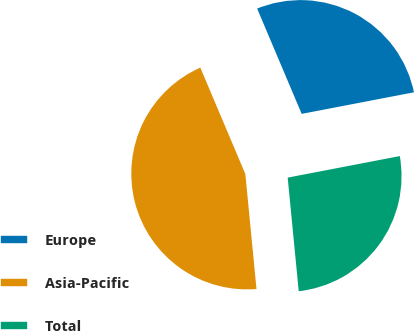Convert chart to OTSL. <chart><loc_0><loc_0><loc_500><loc_500><pie_chart><fcel>Europe<fcel>Asia-Pacific<fcel>Total<nl><fcel>28.35%<fcel>45.17%<fcel>26.48%<nl></chart> 